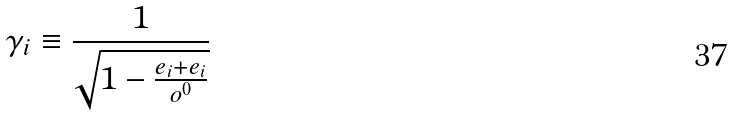Convert formula to latex. <formula><loc_0><loc_0><loc_500><loc_500>\gamma _ { i } \equiv \frac { 1 } { \sqrt { 1 - \frac { e _ { i } + e _ { i } } { o ^ { 0 } } } }</formula> 